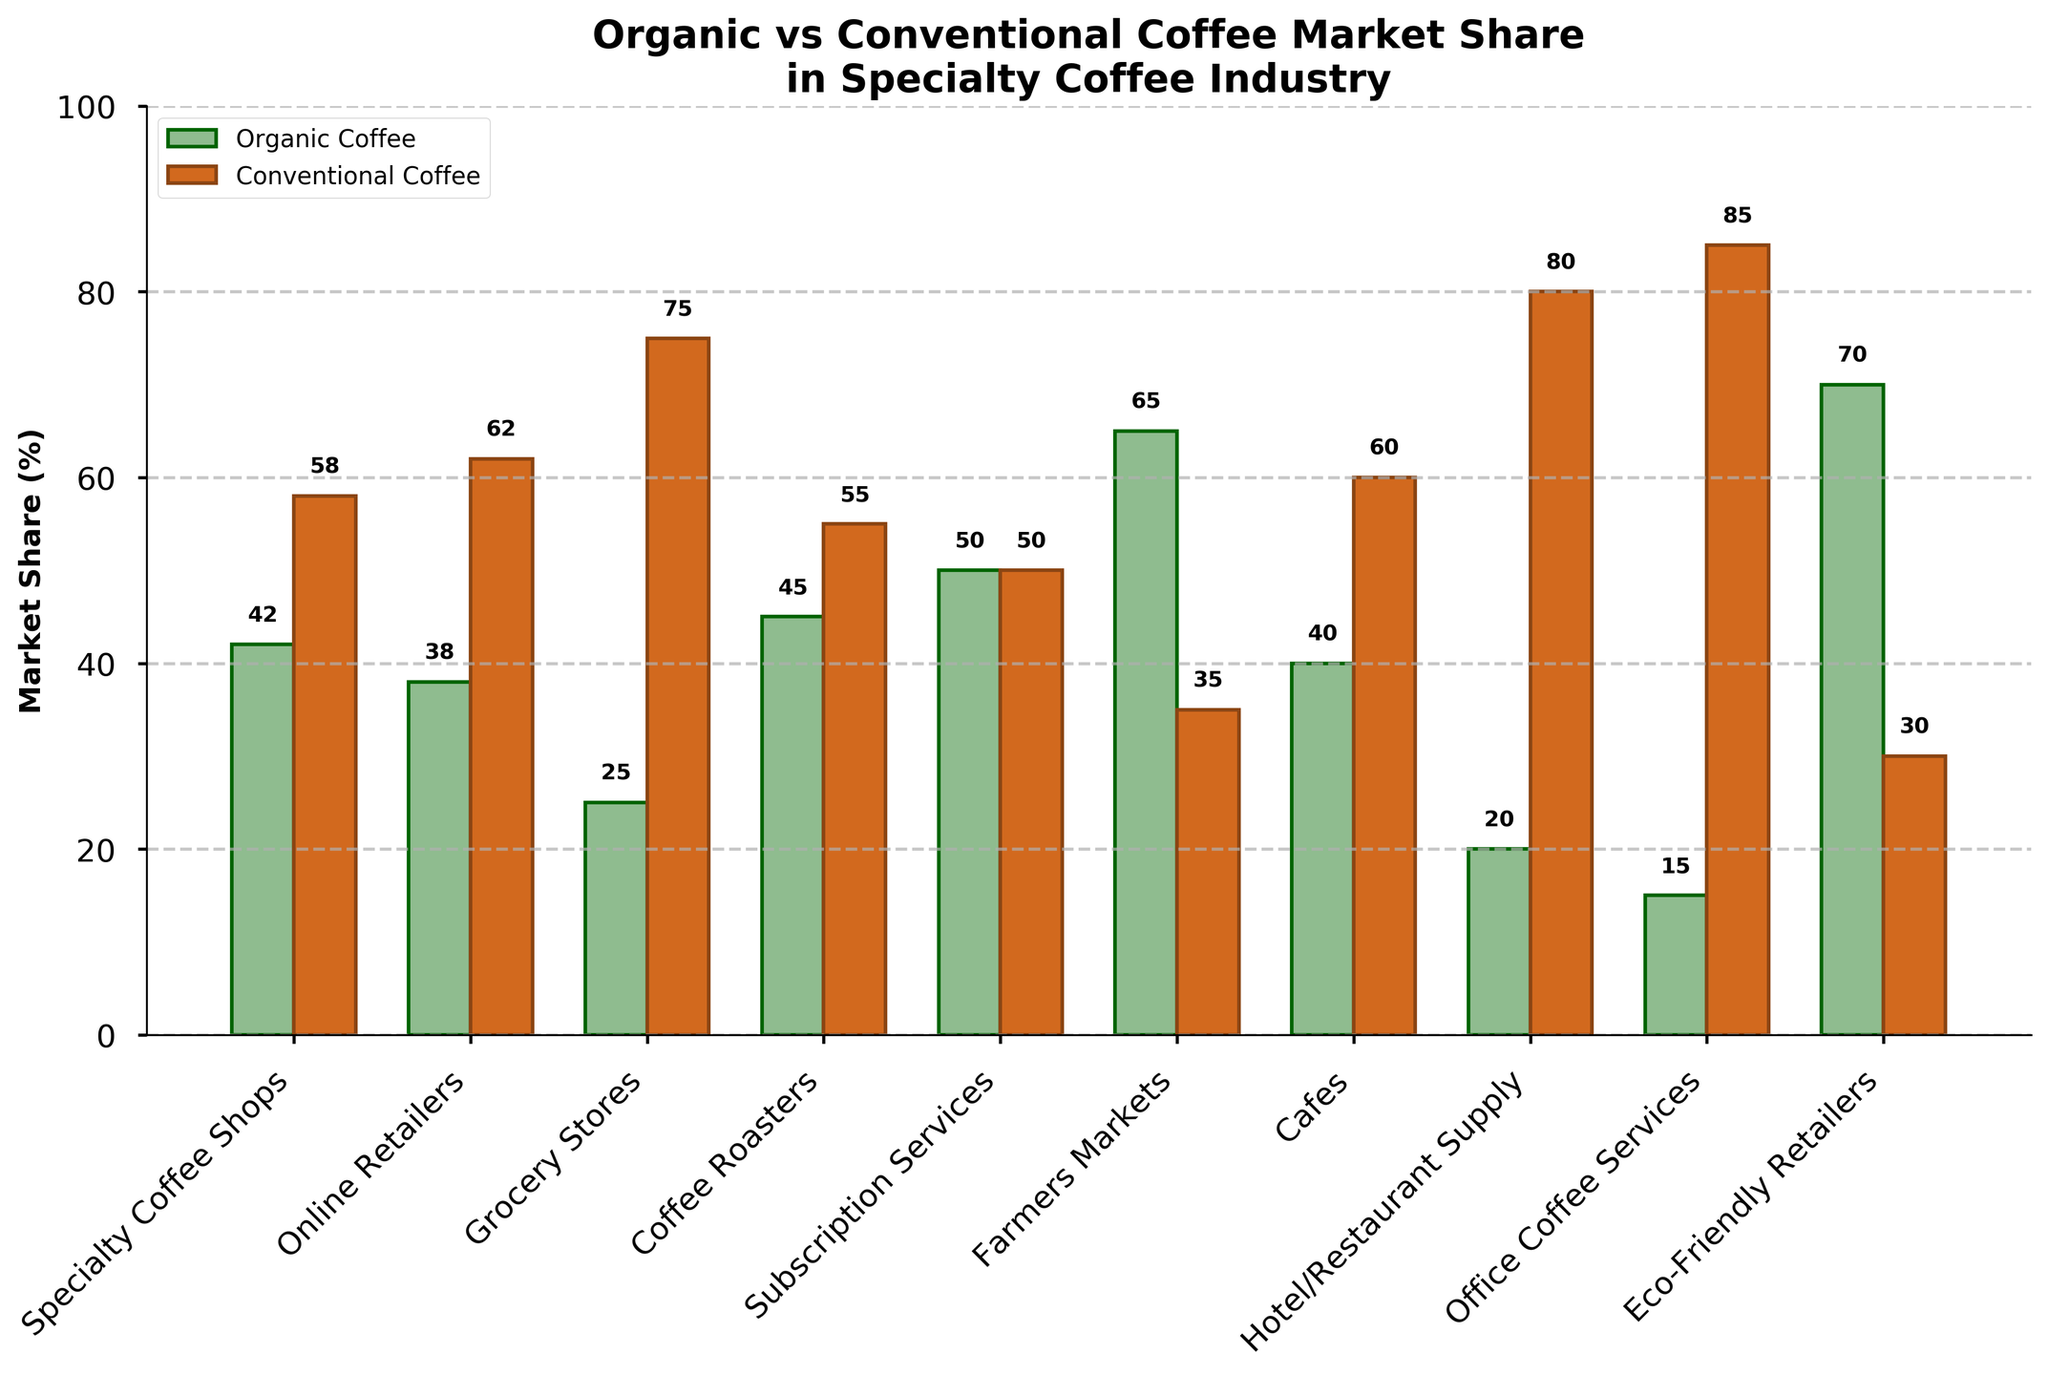What percentage of the market share for organic coffee do Farmers Markets have? Look at the bar for Farmers Markets in the organic coffee segment. The height of the bar and the label above it show the percentage.
Answer: 65% Which market segment has the closest to equal market share between organic and conventional coffee? Check which bar pairs are nearly equal in height and their labels. The segment with closest values would have similar heights and percentages.
Answer: Subscription Services What is the difference in market share between organic and conventional coffee in Specialty Coffee Shops? Subtract the percentage of organic coffee from the percentage of conventional coffee in Specialty Coffee Shops. 58% - 42% = 16%.
Answer: 16% Which category has the lowest market share for organic coffee? Identify the shortest bar in the organic coffee segment and check the label below it to know which market segment it represents.
Answer: Office Coffee Services How many market segments have more than 50% market share for organic coffee? Count the number of bars in the organic coffee segment that reach above the 50% mark on the y-axis.
Answer: 3 What's the sum of the market share percentages for organic coffee across Eco-Friendly Retailers and Farmers Markets? Add the percentages of organic coffee for Eco-Friendly Retailers and Farmers Markets. 70% + 65% = 135%.
Answer: 135% Are there any market segments with exactly equal market share for organic and conventional coffee? Check if there are any pairs of bars that are exactly equal in height and whose labels show the same percentage.
Answer: Yes Which market segment has the greatest difference in market share between organic and conventional coffee? Calculate the differences for each segment and compare.
Answer: Office Coffee Services Which market segment has the smallest market share for conventional coffee? Identify the shortest bar in the conventional coffee segment and check the label below it to know which market segment it represents.
Answer: Farmers Markets 